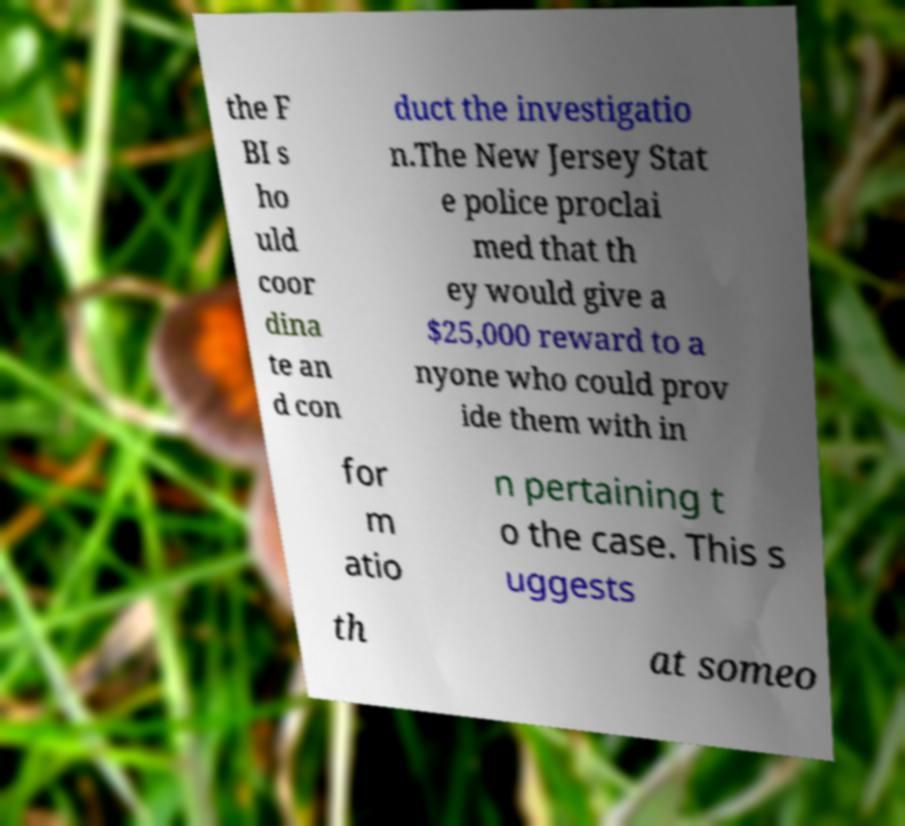What messages or text are displayed in this image? I need them in a readable, typed format. the F BI s ho uld coor dina te an d con duct the investigatio n.The New Jersey Stat e police proclai med that th ey would give a $25,000 reward to a nyone who could prov ide them with in for m atio n pertaining t o the case. This s uggests th at someo 